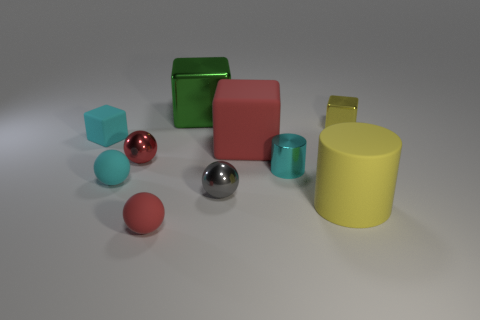What is the shape of the small yellow metal object?
Provide a short and direct response. Cube. Is the shape of the red thing to the right of the green thing the same as  the tiny cyan metal object?
Ensure brevity in your answer.  No. Are there more tiny cyan things that are behind the yellow metal block than small cyan cylinders on the left side of the cyan block?
Provide a succinct answer. No. How many other objects are the same size as the green object?
Give a very brief answer. 2. There is a yellow matte thing; does it have the same shape as the small rubber thing in front of the small gray ball?
Your response must be concise. No. How many metallic objects are cubes or large green blocks?
Give a very brief answer. 2. Are there any other big rubber cylinders that have the same color as the matte cylinder?
Provide a short and direct response. No. Is there a large yellow matte cylinder?
Keep it short and to the point. Yes. Is the shape of the small red matte thing the same as the large metal object?
Make the answer very short. No. What number of large things are matte objects or red things?
Your response must be concise. 2. 